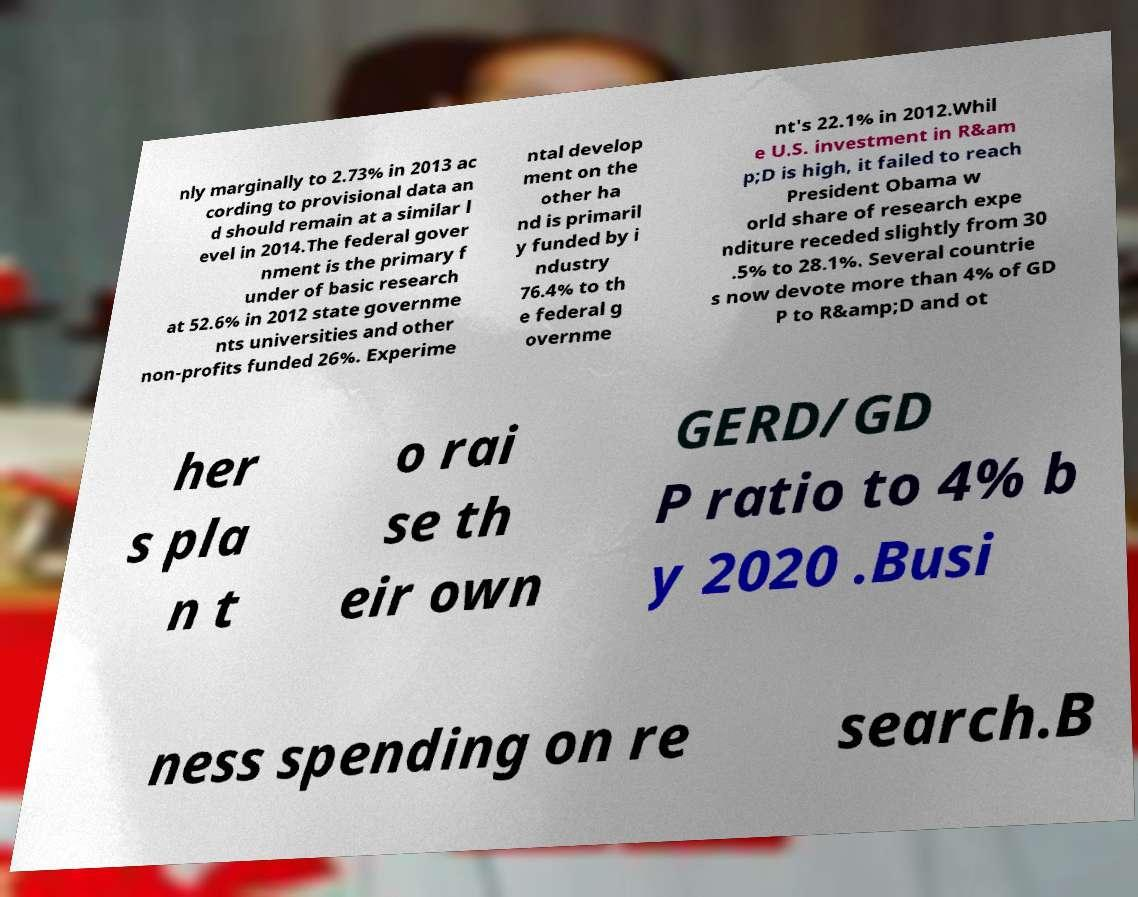Could you assist in decoding the text presented in this image and type it out clearly? nly marginally to 2.73% in 2013 ac cording to provisional data an d should remain at a similar l evel in 2014.The federal gover nment is the primary f under of basic research at 52.6% in 2012 state governme nts universities and other non-profits funded 26%. Experime ntal develop ment on the other ha nd is primaril y funded by i ndustry 76.4% to th e federal g overnme nt's 22.1% in 2012.Whil e U.S. investment in R&am p;D is high, it failed to reach President Obama w orld share of research expe nditure receded slightly from 30 .5% to 28.1%. Several countrie s now devote more than 4% of GD P to R&amp;D and ot her s pla n t o rai se th eir own GERD/GD P ratio to 4% b y 2020 .Busi ness spending on re search.B 